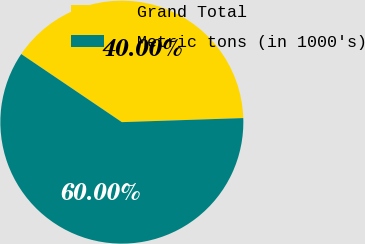<chart> <loc_0><loc_0><loc_500><loc_500><pie_chart><fcel>Grand Total<fcel>Metric tons (in 1000's)<nl><fcel>40.0%<fcel>60.0%<nl></chart> 